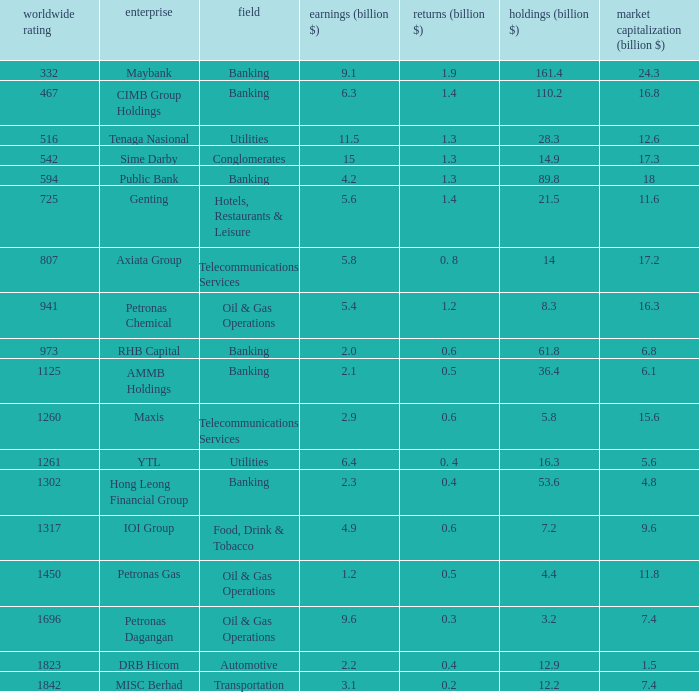Specify the gains for market value of 1 0.5. 